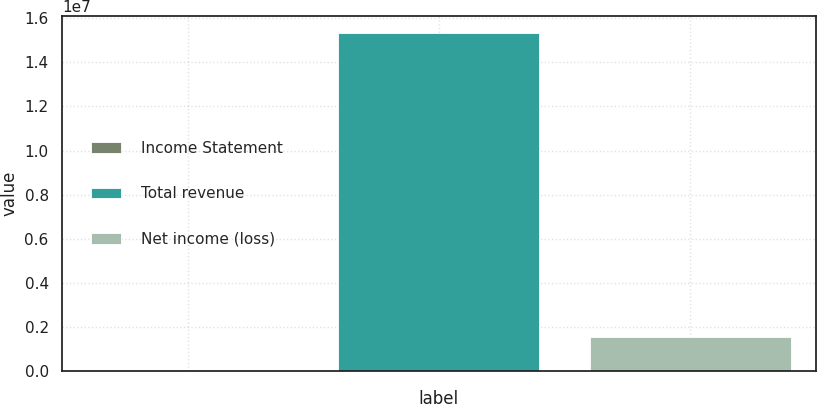Convert chart. <chart><loc_0><loc_0><loc_500><loc_500><bar_chart><fcel>Income Statement<fcel>Total revenue<fcel>Net income (loss)<nl><fcel>2008<fcel>1.5313e+07<fcel>1.53311e+06<nl></chart> 